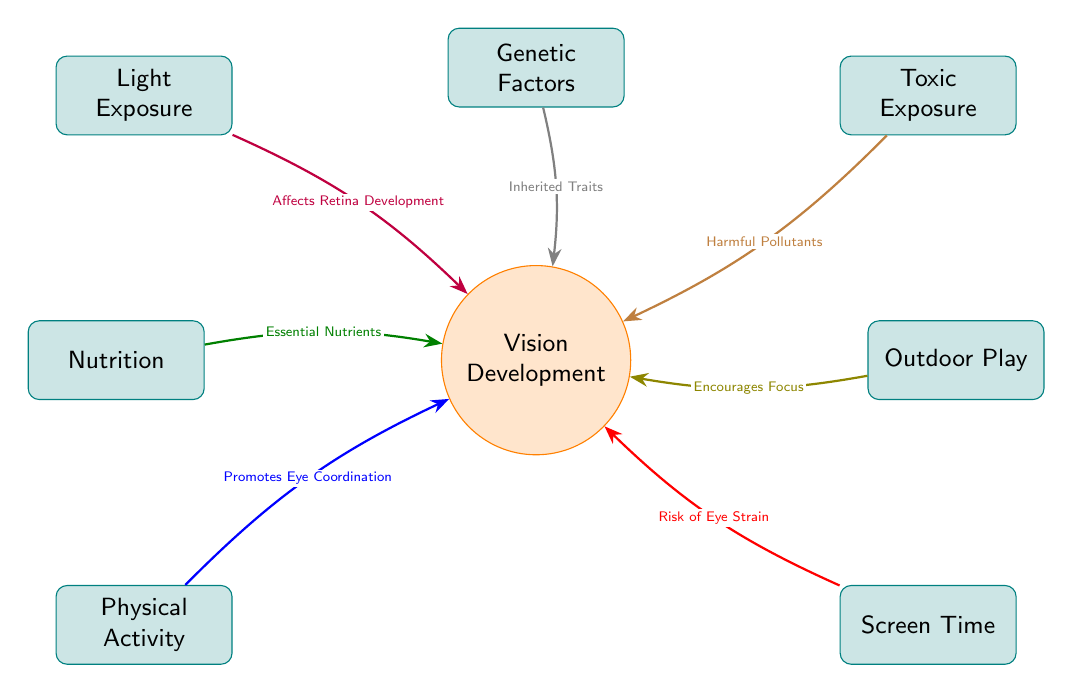What is at the center of the diagram? The central node labeled "Vision Development" represents the main focus of the diagram. It is the core around which all other factors are connected.
Answer: Vision Development How many factors influence vision development? There are a total of six surrounding factors that influence vision development, each depicted in separate nodes.
Answer: 6 Which factor is associated with "Affects Retina Development"? The factor "Light Exposure" has the relationship "Affects Retina Development" directed toward the central node, indicating its impact on vision development.
Answer: Light Exposure What is the relationship between "Nutrition" and vision development? The connection from the "Nutrition" node to the central node states "Essential Nutrients", indicating the role of nutrition in supporting vision development.
Answer: Essential Nutrients Which factor indicates a risk associated with extended usage? The factor "Screen Time" is linked to vision development through the relationship "Risk of Eye Strain", highlighting the potential negative effects of screen exposure.
Answer: Risk of Eye Strain What impact does "Outdoor Play" have on vision development? "Outdoor Play" is connected to "Vision Development" with the label "Encourages Focus", suggesting that spending time outdoors aids in focusing abilities for vision.
Answer: Encourages Focus If someone has a genetic predisposition to vision problems, which factor would be relevant? The factor "Genetic Factors" is related to vision development as it involves "Inherited Traits", indicating the relevance of genetics in visual capabilities.
Answer: Inherited Traits What type of exposures are represented by the "Toxic Exposure" factor? "Toxic Exposure" is identified in the diagram to indicate "Harmful Pollutants", emphasizing environmental factors that can negatively influence vision development.
Answer: Harmful Pollutants How does "Physical Activity" contribute to vision development? The connection from "Physical Activity" to "Vision Development" states "Promotes Eye Coordination", indicating that physical activity is beneficial for developing coordination skills important for vision.
Answer: Promotes Eye Coordination 